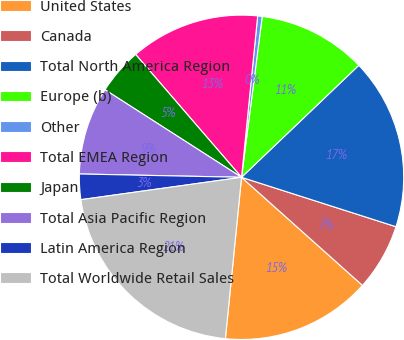<chart> <loc_0><loc_0><loc_500><loc_500><pie_chart><fcel>United States<fcel>Canada<fcel>Total North America Region<fcel>Europe (b)<fcel>Other<fcel>Total EMEA Region<fcel>Japan<fcel>Total Asia Pacific Region<fcel>Latin America Region<fcel>Total Worldwide Retail Sales<nl><fcel>14.98%<fcel>6.68%<fcel>17.06%<fcel>10.83%<fcel>0.45%<fcel>12.91%<fcel>4.6%<fcel>8.75%<fcel>2.53%<fcel>21.21%<nl></chart> 